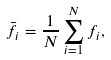Convert formula to latex. <formula><loc_0><loc_0><loc_500><loc_500>\bar { f _ { i } } = \frac { 1 } { N } \sum _ { i = 1 } ^ { N } f _ { i } ,</formula> 